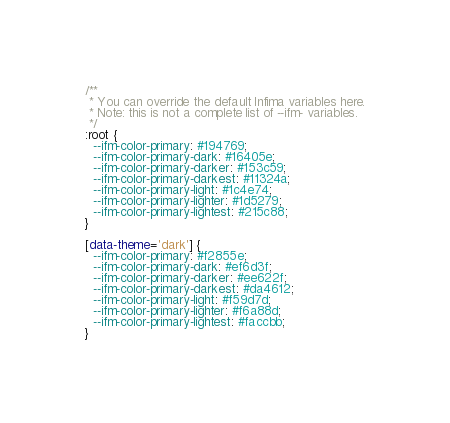<code> <loc_0><loc_0><loc_500><loc_500><_CSS_>/**
 * You can override the default Infima variables here.
 * Note: this is not a complete list of --ifm- variables.
 */
:root {
  --ifm-color-primary: #194769;
  --ifm-color-primary-dark: #16405e;
  --ifm-color-primary-darker: #153c59;
  --ifm-color-primary-darkest: #11324a;
  --ifm-color-primary-light: #1c4e74;
  --ifm-color-primary-lighter: #1d5279;
  --ifm-color-primary-lightest: #215c88;
}

[data-theme='dark'] {
  --ifm-color-primary: #f2855e;
  --ifm-color-primary-dark: #ef6d3f;
  --ifm-color-primary-darker: #ee622f;
  --ifm-color-primary-darkest: #da4612;
  --ifm-color-primary-light: #f59d7d;
  --ifm-color-primary-lighter: #f6a88d;
  --ifm-color-primary-lightest: #faccbb;
}
</code> 